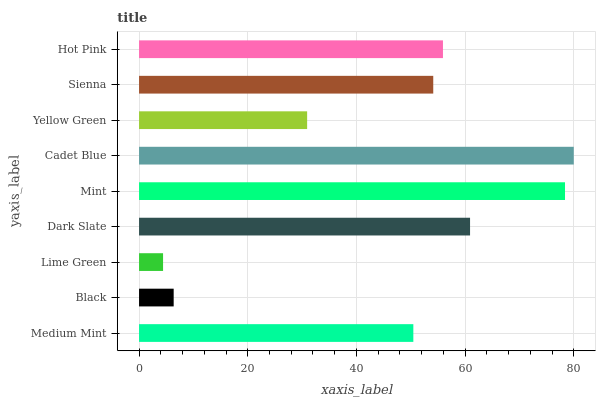Is Lime Green the minimum?
Answer yes or no. Yes. Is Cadet Blue the maximum?
Answer yes or no. Yes. Is Black the minimum?
Answer yes or no. No. Is Black the maximum?
Answer yes or no. No. Is Medium Mint greater than Black?
Answer yes or no. Yes. Is Black less than Medium Mint?
Answer yes or no. Yes. Is Black greater than Medium Mint?
Answer yes or no. No. Is Medium Mint less than Black?
Answer yes or no. No. Is Sienna the high median?
Answer yes or no. Yes. Is Sienna the low median?
Answer yes or no. Yes. Is Yellow Green the high median?
Answer yes or no. No. Is Mint the low median?
Answer yes or no. No. 